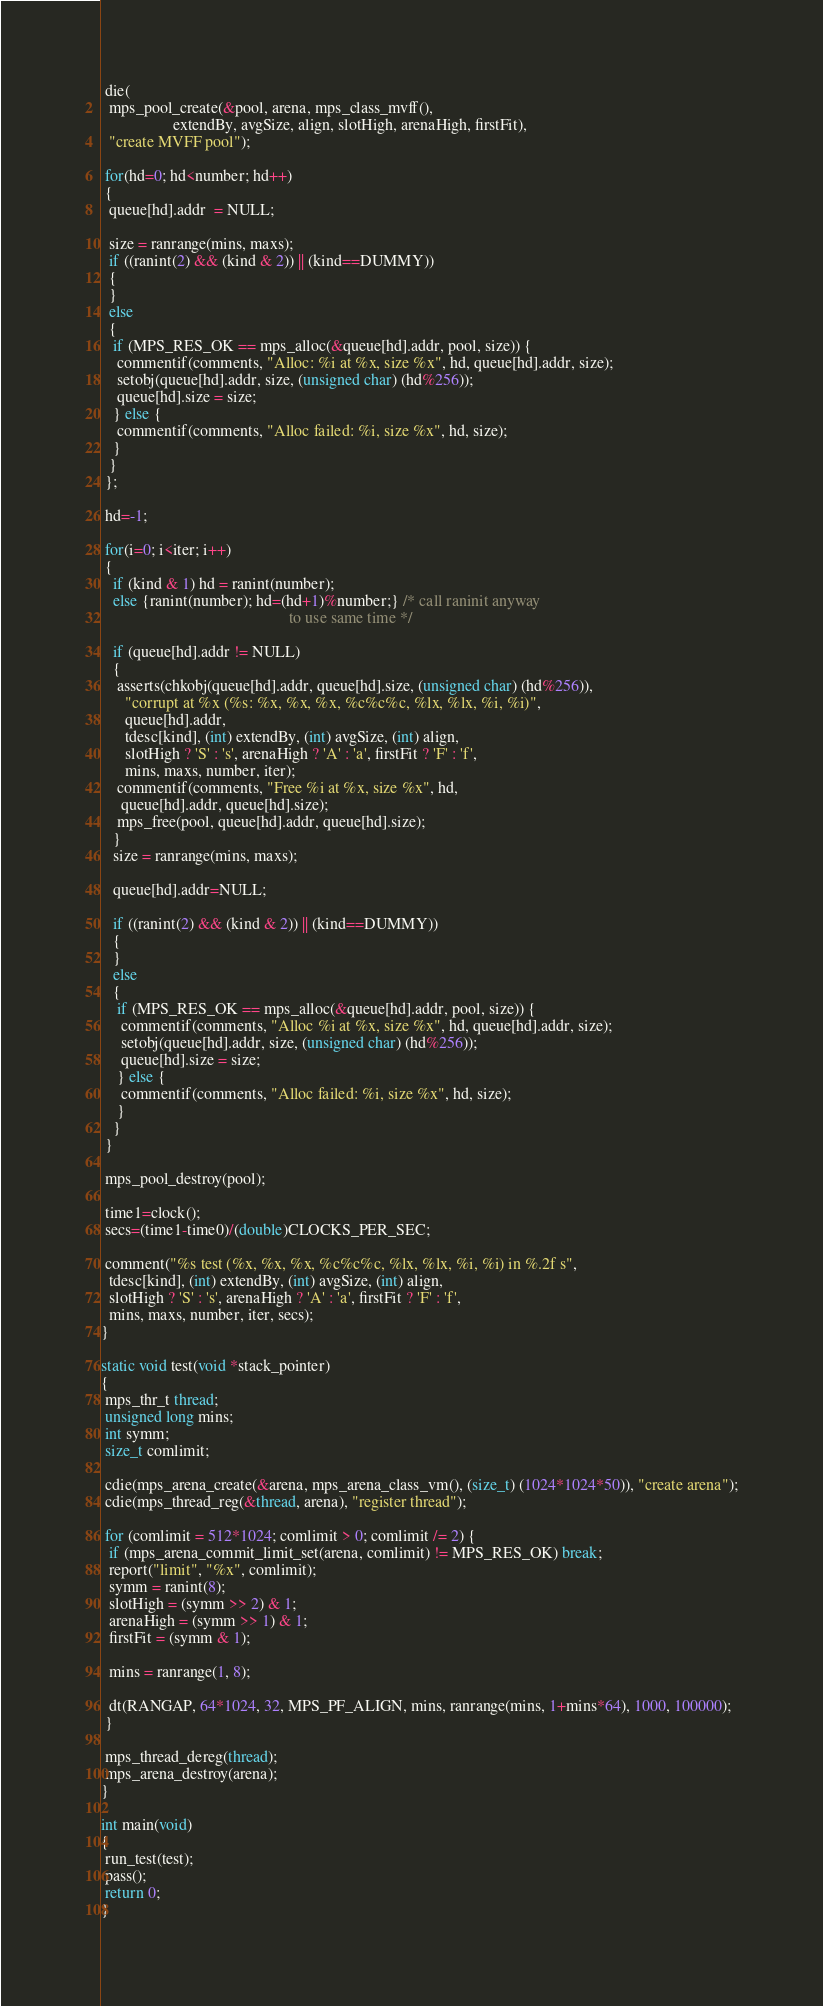Convert code to text. <code><loc_0><loc_0><loc_500><loc_500><_C_>
 die(
  mps_pool_create(&pool, arena, mps_class_mvff(),
                  extendBy, avgSize, align, slotHigh, arenaHigh, firstFit),
  "create MVFF pool");

 for(hd=0; hd<number; hd++)
 {
  queue[hd].addr  = NULL;

  size = ranrange(mins, maxs);
  if ((ranint(2) && (kind & 2)) || (kind==DUMMY))
  {
  }
  else
  {
   if (MPS_RES_OK == mps_alloc(&queue[hd].addr, pool, size)) {
    commentif(comments, "Alloc: %i at %x, size %x", hd, queue[hd].addr, size);
    setobj(queue[hd].addr, size, (unsigned char) (hd%256));
    queue[hd].size = size;
   } else {
    commentif(comments, "Alloc failed: %i, size %x", hd, size);
   }
  }
 };

 hd=-1;

 for(i=0; i<iter; i++)
 {
   if (kind & 1) hd = ranint(number);
   else {ranint(number); hd=(hd+1)%number;} /* call raninit anyway
                                               to use same time */

   if (queue[hd].addr != NULL)
   {
    asserts(chkobj(queue[hd].addr, queue[hd].size, (unsigned char) (hd%256)),
      "corrupt at %x (%s: %x, %x, %x, %c%c%c, %lx, %lx, %i, %i)",
      queue[hd].addr,
      tdesc[kind], (int) extendBy, (int) avgSize, (int) align,
      slotHigh ? 'S' : 's', arenaHigh ? 'A' : 'a', firstFit ? 'F' : 'f',
      mins, maxs, number, iter);
    commentif(comments, "Free %i at %x, size %x", hd,
     queue[hd].addr, queue[hd].size);
    mps_free(pool, queue[hd].addr, queue[hd].size);
   }
   size = ranrange(mins, maxs);

   queue[hd].addr=NULL;

   if ((ranint(2) && (kind & 2)) || (kind==DUMMY))
   {
   }
   else
   {
    if (MPS_RES_OK == mps_alloc(&queue[hd].addr, pool, size)) {
     commentif(comments, "Alloc %i at %x, size %x", hd, queue[hd].addr, size);
     setobj(queue[hd].addr, size, (unsigned char) (hd%256));
     queue[hd].size = size;
    } else {
     commentif(comments, "Alloc failed: %i, size %x", hd, size);
    }
   }
 }

 mps_pool_destroy(pool);

 time1=clock();
 secs=(time1-time0)/(double)CLOCKS_PER_SEC;

 comment("%s test (%x, %x, %x, %c%c%c, %lx, %lx, %i, %i) in %.2f s",
  tdesc[kind], (int) extendBy, (int) avgSize, (int) align,
  slotHigh ? 'S' : 's', arenaHigh ? 'A' : 'a', firstFit ? 'F' : 'f',
  mins, maxs, number, iter, secs);
}

static void test(void *stack_pointer)
{
 mps_thr_t thread;
 unsigned long mins;
 int symm;
 size_t comlimit;

 cdie(mps_arena_create(&arena, mps_arena_class_vm(), (size_t) (1024*1024*50)), "create arena");
 cdie(mps_thread_reg(&thread, arena), "register thread");

 for (comlimit = 512*1024; comlimit > 0; comlimit /= 2) {
  if (mps_arena_commit_limit_set(arena, comlimit) != MPS_RES_OK) break;
  report("limit", "%x", comlimit);
  symm = ranint(8);
  slotHigh = (symm >> 2) & 1;
  arenaHigh = (symm >> 1) & 1;
  firstFit = (symm & 1);

  mins = ranrange(1, 8);

  dt(RANGAP, 64*1024, 32, MPS_PF_ALIGN, mins, ranrange(mins, 1+mins*64), 1000, 100000);
 }

 mps_thread_dereg(thread);
 mps_arena_destroy(arena);
}

int main(void)
{
 run_test(test);
 pass();
 return 0;
}
</code> 